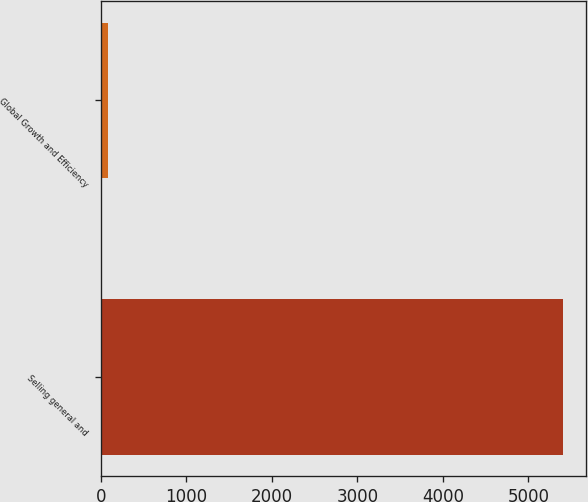<chart> <loc_0><loc_0><loc_500><loc_500><bar_chart><fcel>Selling general and<fcel>Global Growth and Efficiency<nl><fcel>5408<fcel>89<nl></chart> 